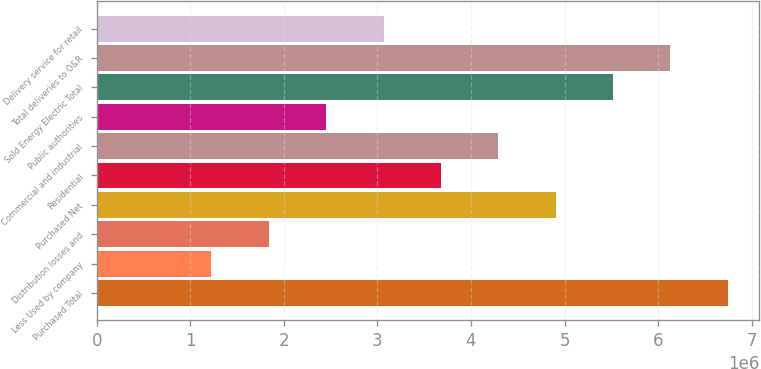Convert chart to OTSL. <chart><loc_0><loc_0><loc_500><loc_500><bar_chart><fcel>Purchased Total<fcel>Less Used by company<fcel>Distribution losses and<fcel>Purchased Net<fcel>Residential<fcel>Commercial and industrial<fcel>Public authorities<fcel>Sold Energy Electric Total<fcel>Total deliveries to O&R<fcel>Delivery service for retail<nl><fcel>6.74437e+06<fcel>1.22626e+06<fcel>1.83938e+06<fcel>4.905e+06<fcel>3.67875e+06<fcel>4.29188e+06<fcel>2.45251e+06<fcel>5.51812e+06<fcel>6.13125e+06<fcel>3.06563e+06<nl></chart> 